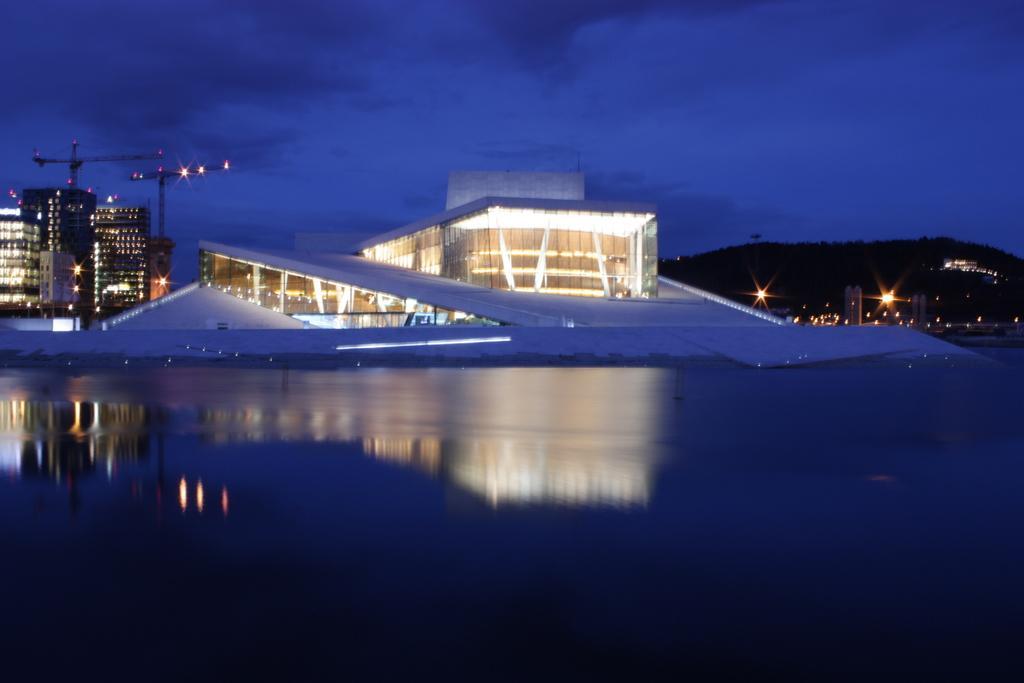Describe this image in one or two sentences. At the bottom of this image, there is water. In the background, there are buildings which are having lighting, there is a mountain and there are clouds in the sky. 